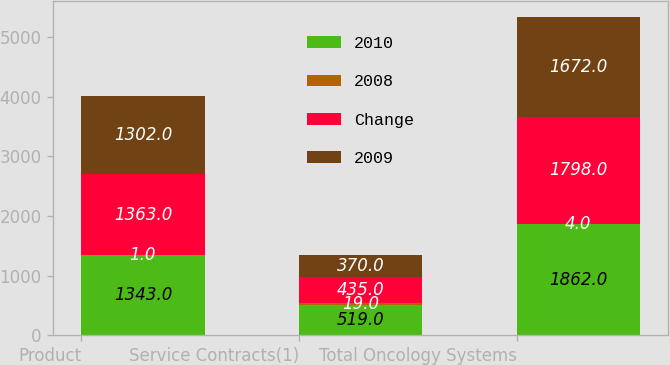<chart> <loc_0><loc_0><loc_500><loc_500><stacked_bar_chart><ecel><fcel>Product<fcel>Service Contracts(1)<fcel>Total Oncology Systems<nl><fcel>2010<fcel>1343<fcel>519<fcel>1862<nl><fcel>2008<fcel>1<fcel>19<fcel>4<nl><fcel>Change<fcel>1363<fcel>435<fcel>1798<nl><fcel>2009<fcel>1302<fcel>370<fcel>1672<nl></chart> 